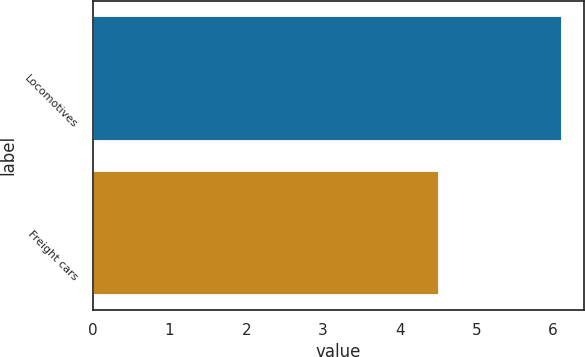Convert chart to OTSL. <chart><loc_0><loc_0><loc_500><loc_500><bar_chart><fcel>Locomotives<fcel>Freight cars<nl><fcel>6.1<fcel>4.5<nl></chart> 